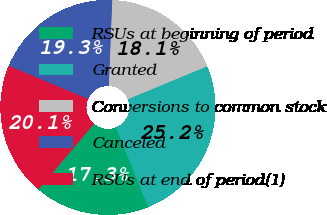Convert chart to OTSL. <chart><loc_0><loc_0><loc_500><loc_500><pie_chart><fcel>RSUs at beginning of period<fcel>Granted<fcel>Conversions to common stock<fcel>Canceled<fcel>RSUs at end of period(1)<nl><fcel>17.3%<fcel>25.15%<fcel>18.09%<fcel>19.33%<fcel>20.12%<nl></chart> 